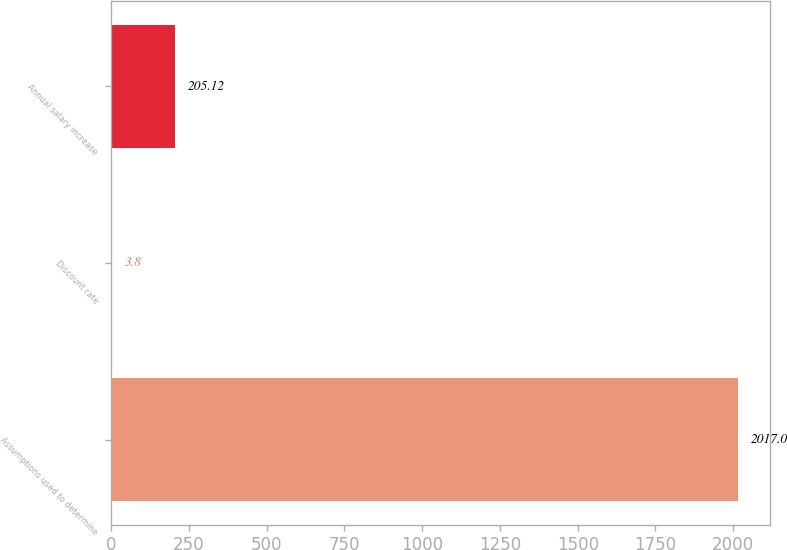Convert chart to OTSL. <chart><loc_0><loc_0><loc_500><loc_500><bar_chart><fcel>Assumptions used to determine<fcel>Discount rate<fcel>Annual salary increase<nl><fcel>2017<fcel>3.8<fcel>205.12<nl></chart> 